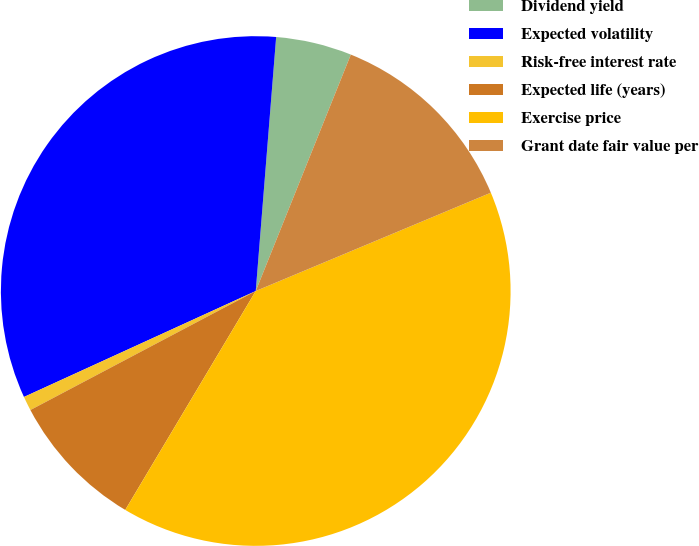Convert chart. <chart><loc_0><loc_0><loc_500><loc_500><pie_chart><fcel>Dividend yield<fcel>Expected volatility<fcel>Risk-free interest rate<fcel>Expected life (years)<fcel>Exercise price<fcel>Grant date fair value per<nl><fcel>4.81%<fcel>33.1%<fcel>0.91%<fcel>8.71%<fcel>39.86%<fcel>12.61%<nl></chart> 